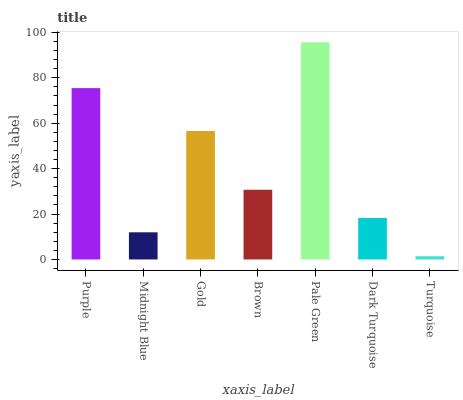Is Turquoise the minimum?
Answer yes or no. Yes. Is Pale Green the maximum?
Answer yes or no. Yes. Is Midnight Blue the minimum?
Answer yes or no. No. Is Midnight Blue the maximum?
Answer yes or no. No. Is Purple greater than Midnight Blue?
Answer yes or no. Yes. Is Midnight Blue less than Purple?
Answer yes or no. Yes. Is Midnight Blue greater than Purple?
Answer yes or no. No. Is Purple less than Midnight Blue?
Answer yes or no. No. Is Brown the high median?
Answer yes or no. Yes. Is Brown the low median?
Answer yes or no. Yes. Is Gold the high median?
Answer yes or no. No. Is Dark Turquoise the low median?
Answer yes or no. No. 